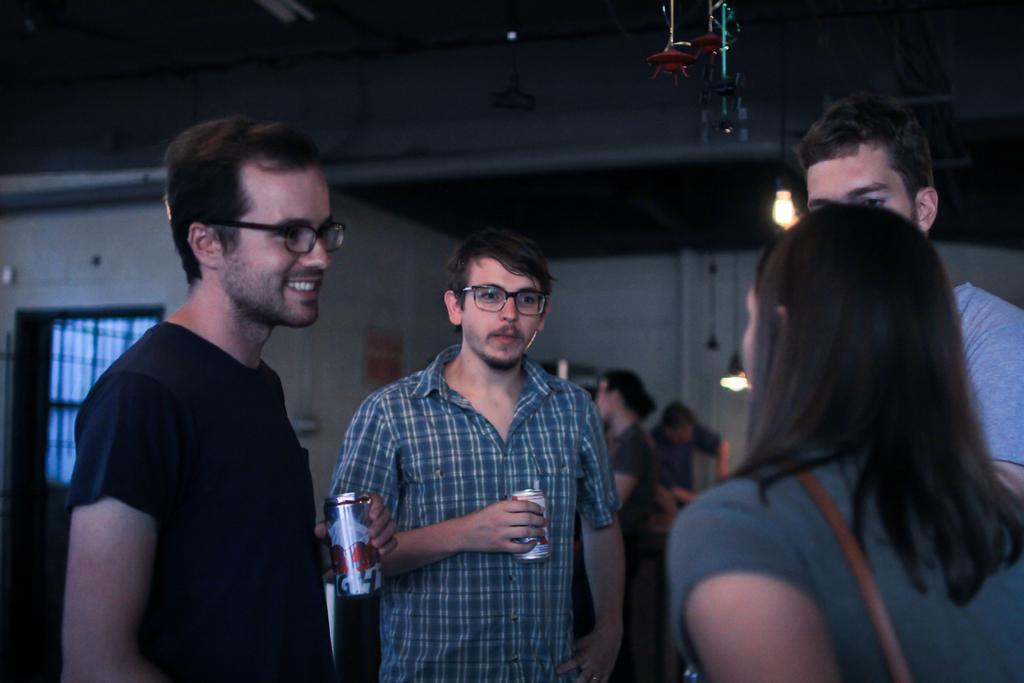In one or two sentences, can you explain what this image depicts? This picture is clicked inside the room. In this picture, we see three men are standing. The woman in grey T-shirt is standing. I think she is talking to them. The man on the left side who is wearing black T-shirt is holding a coke bottle in his hand. Beside him, the man who is wearing spectacles is also holding a coke bottle in his hand. Behind them, we see people are standing. In the background, we see a white wall and window. 